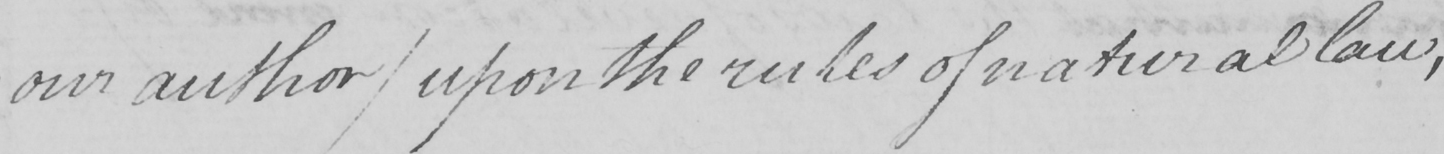Please provide the text content of this handwritten line. " our author )  upon the rules of natural law , 